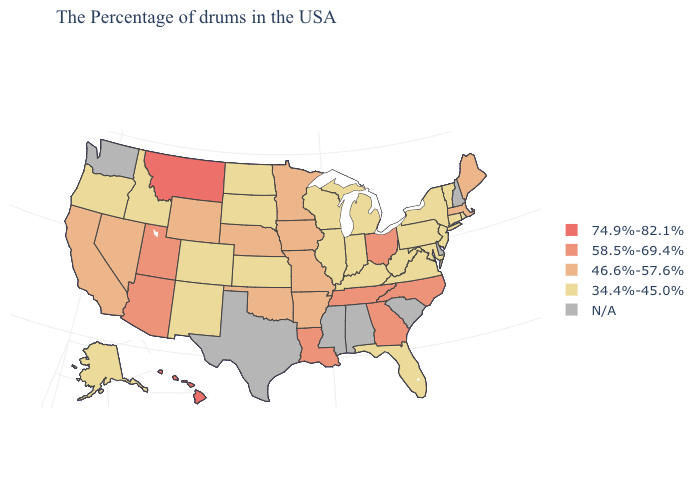What is the highest value in states that border Iowa?
Be succinct. 46.6%-57.6%. What is the value of Vermont?
Answer briefly. 34.4%-45.0%. What is the lowest value in states that border Colorado?
Keep it brief. 34.4%-45.0%. Name the states that have a value in the range N/A?
Answer briefly. New Hampshire, Delaware, South Carolina, Alabama, Mississippi, Texas, Washington. Does Hawaii have the highest value in the USA?
Short answer required. Yes. What is the lowest value in the South?
Give a very brief answer. 34.4%-45.0%. What is the value of Mississippi?
Write a very short answer. N/A. What is the highest value in the West ?
Be succinct. 74.9%-82.1%. Name the states that have a value in the range 46.6%-57.6%?
Quick response, please. Maine, Massachusetts, Missouri, Arkansas, Minnesota, Iowa, Nebraska, Oklahoma, Wyoming, Nevada, California. Does the first symbol in the legend represent the smallest category?
Keep it brief. No. What is the value of Connecticut?
Give a very brief answer. 34.4%-45.0%. Among the states that border Minnesota , does Iowa have the highest value?
Give a very brief answer. Yes. Does Rhode Island have the lowest value in the Northeast?
Concise answer only. Yes. 